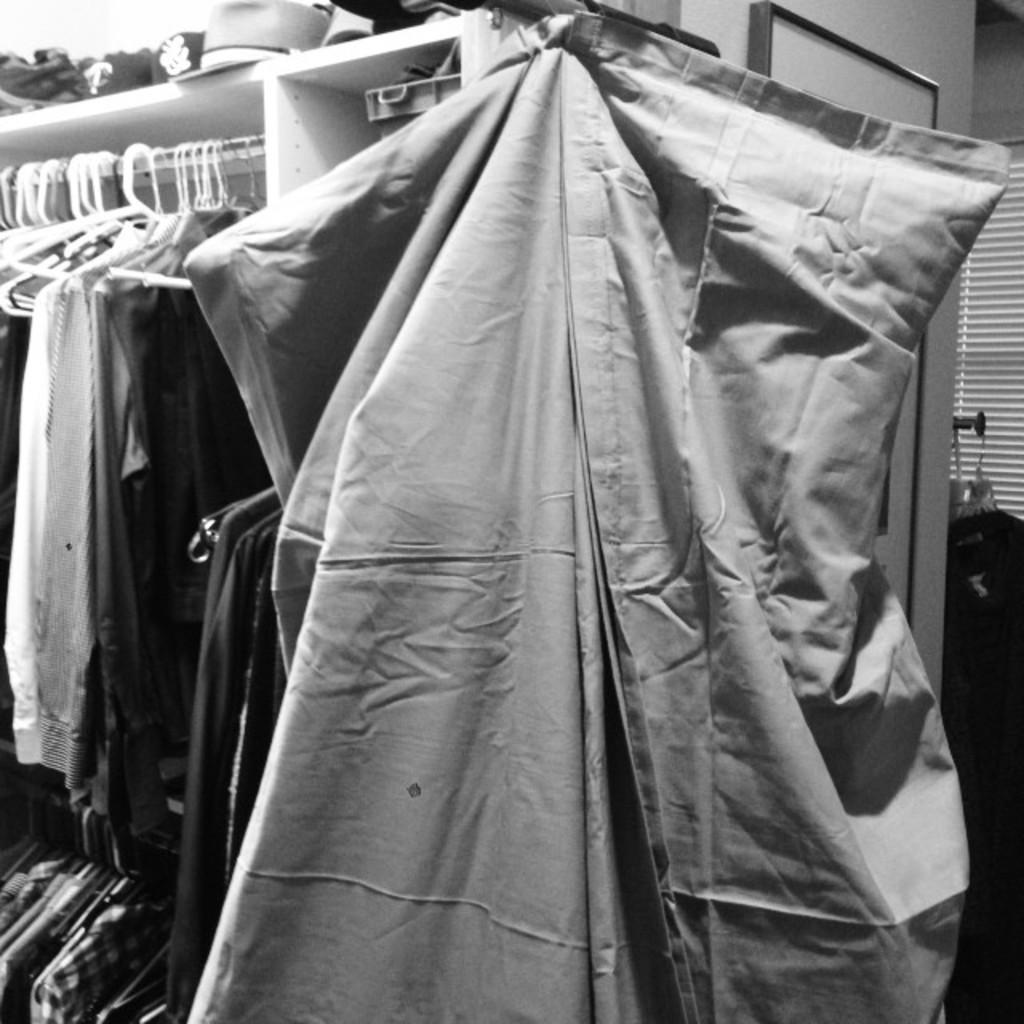What is the color scheme of the image? The image is black and white. What type of objects can be seen in the image? There are clothes in the image. What type of tooth is visible in the image? There is no tooth present in the image. Is there a whip being used in the image? There is no whip present in the image. 